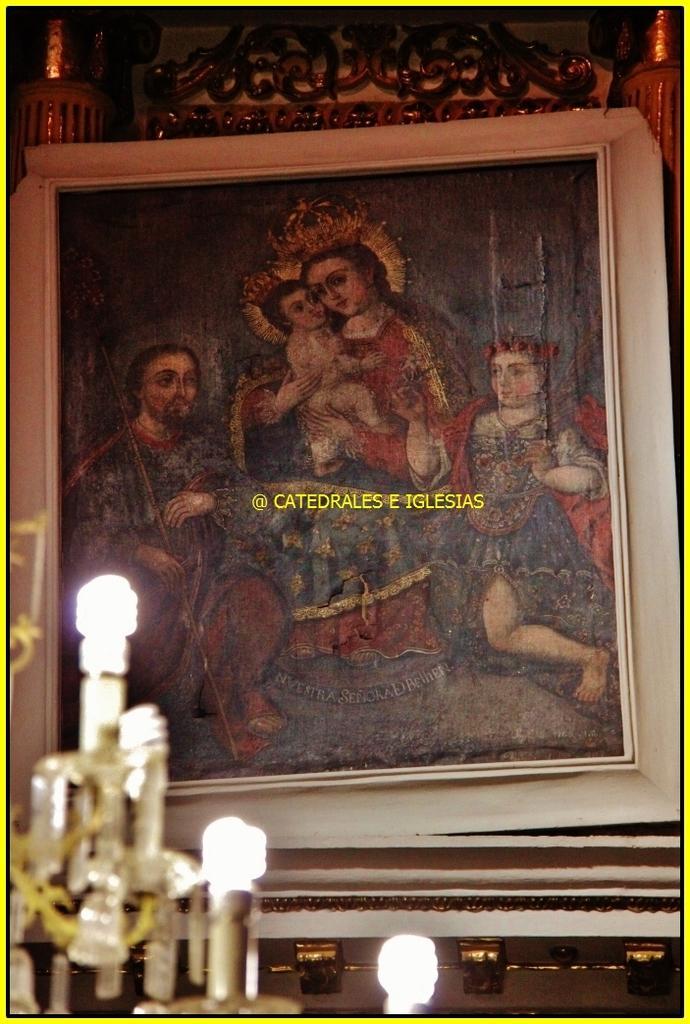Can you describe this image briefly? On the left side of the image we can see few lights, in the background we can find a frame on the wall, and we can see some text on the frame. 